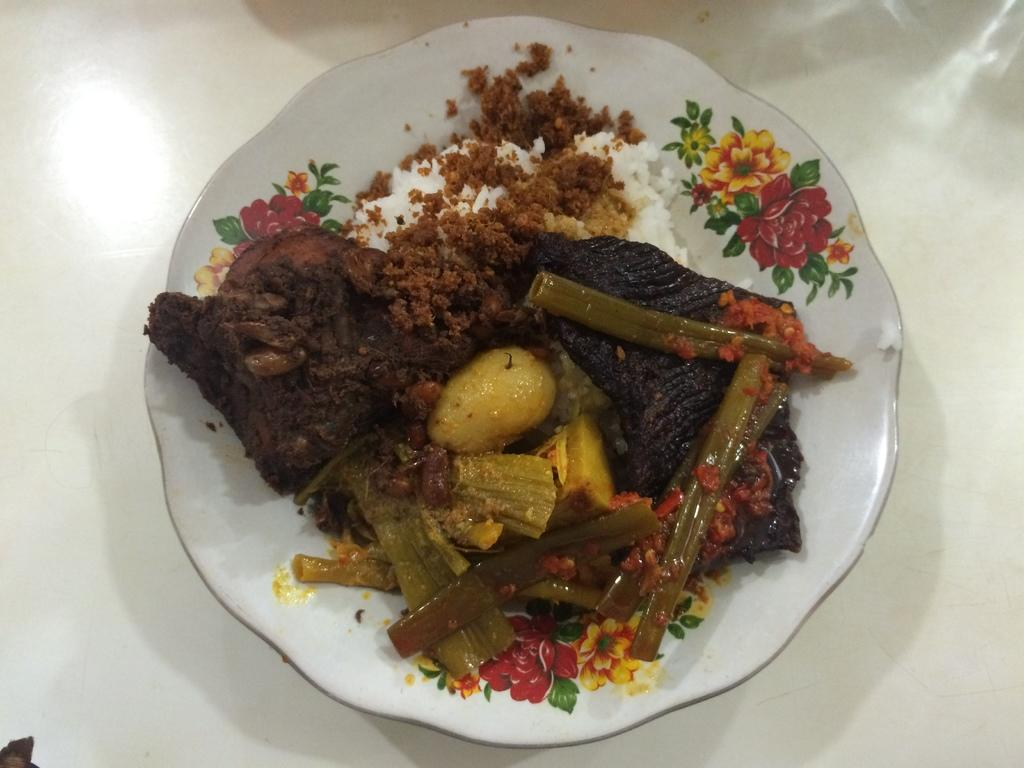What is on the plate that is visible in the image? There is a plate with food in the image. What colors can be seen on the plate? The plate has white, red, yellow, and green colors. How would you describe the food on the plate? The food on the plate is colorful. What is the color of the surface the plate is on? The plate is on a white color surface. How many rabbits can be seen in the image? There are no rabbits present in the image. 